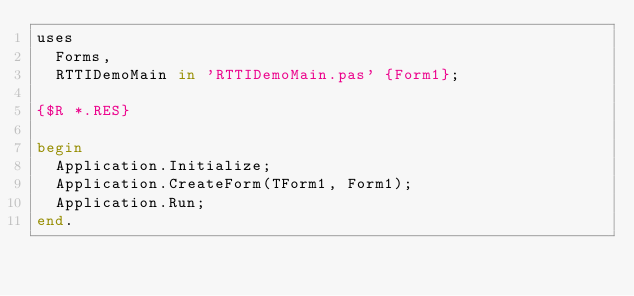Convert code to text. <code><loc_0><loc_0><loc_500><loc_500><_Pascal_>uses
  Forms,
  RTTIDemoMain in 'RTTIDemoMain.pas' {Form1};

{$R *.RES}

begin
  Application.Initialize;
  Application.CreateForm(TForm1, Form1);
  Application.Run;
end.
</code> 